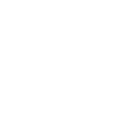Convert code to text. <code><loc_0><loc_0><loc_500><loc_500><_SQL_>
</code> 